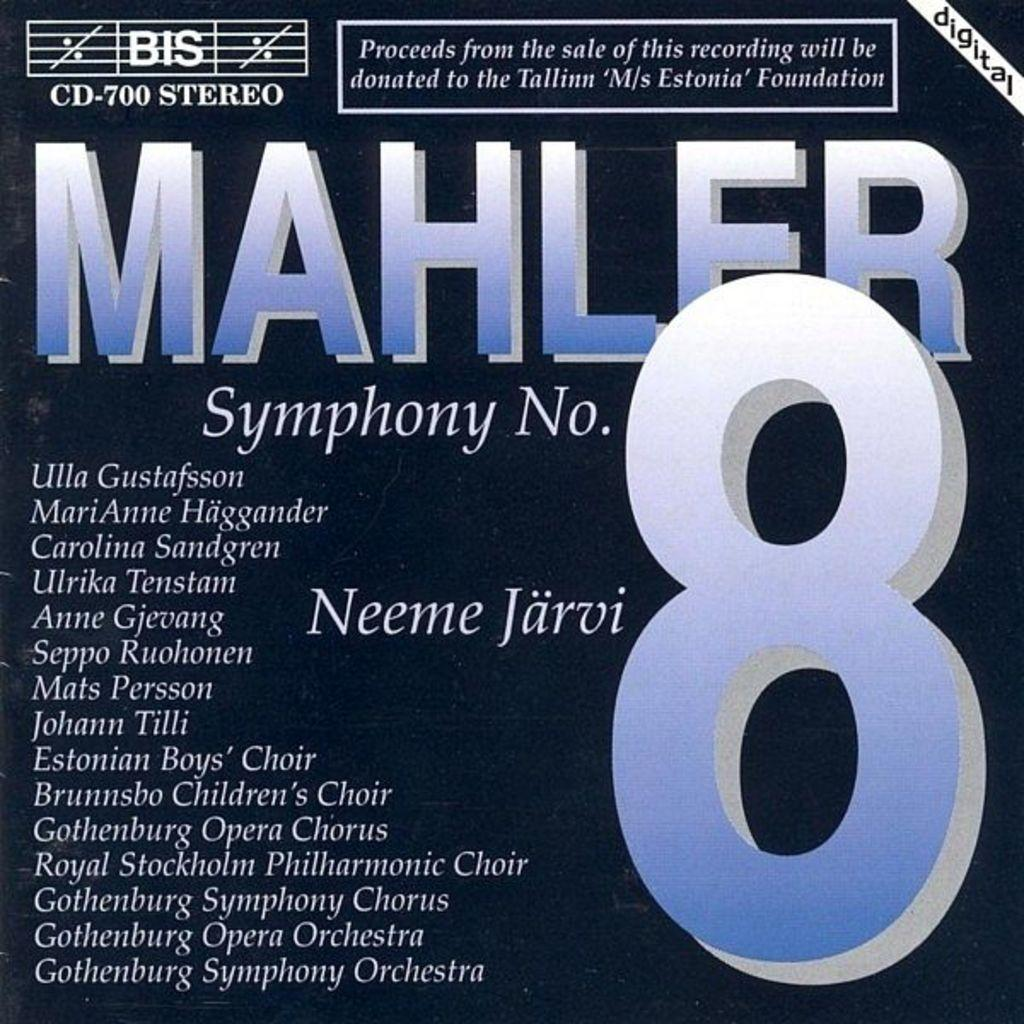<image>
Render a clear and concise summary of the photo. a music sheet with the number 8 on it 